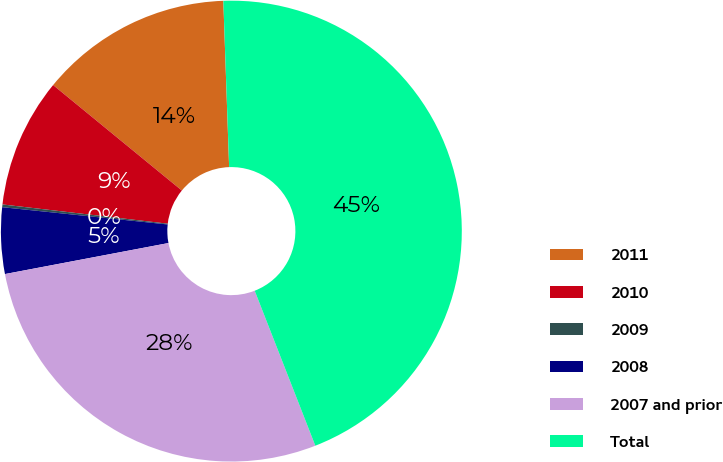Convert chart to OTSL. <chart><loc_0><loc_0><loc_500><loc_500><pie_chart><fcel>2011<fcel>2010<fcel>2009<fcel>2008<fcel>2007 and prior<fcel>Total<nl><fcel>13.52%<fcel>9.08%<fcel>0.19%<fcel>4.64%<fcel>27.95%<fcel>44.62%<nl></chart> 